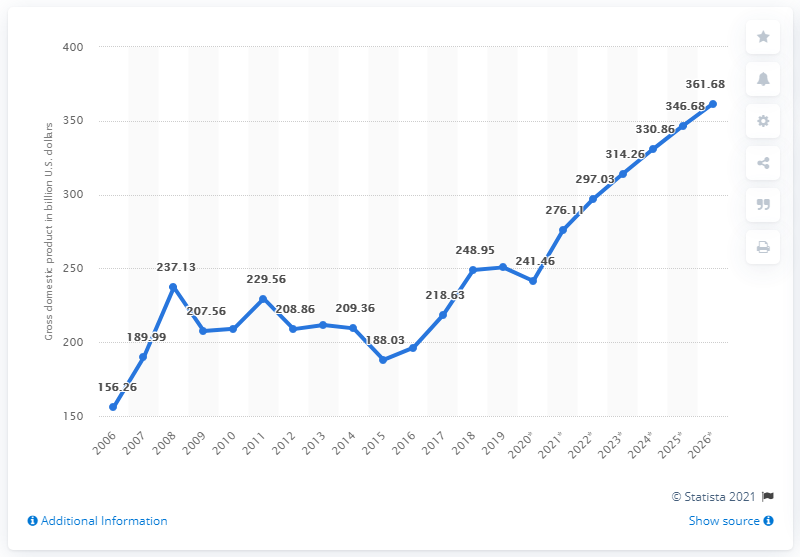Indicate a few pertinent items in this graphic. In the year 2019, the gross domestic product of the Czech Republic was 250.69. 